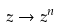<formula> <loc_0><loc_0><loc_500><loc_500>z \rightarrow z ^ { n }</formula> 